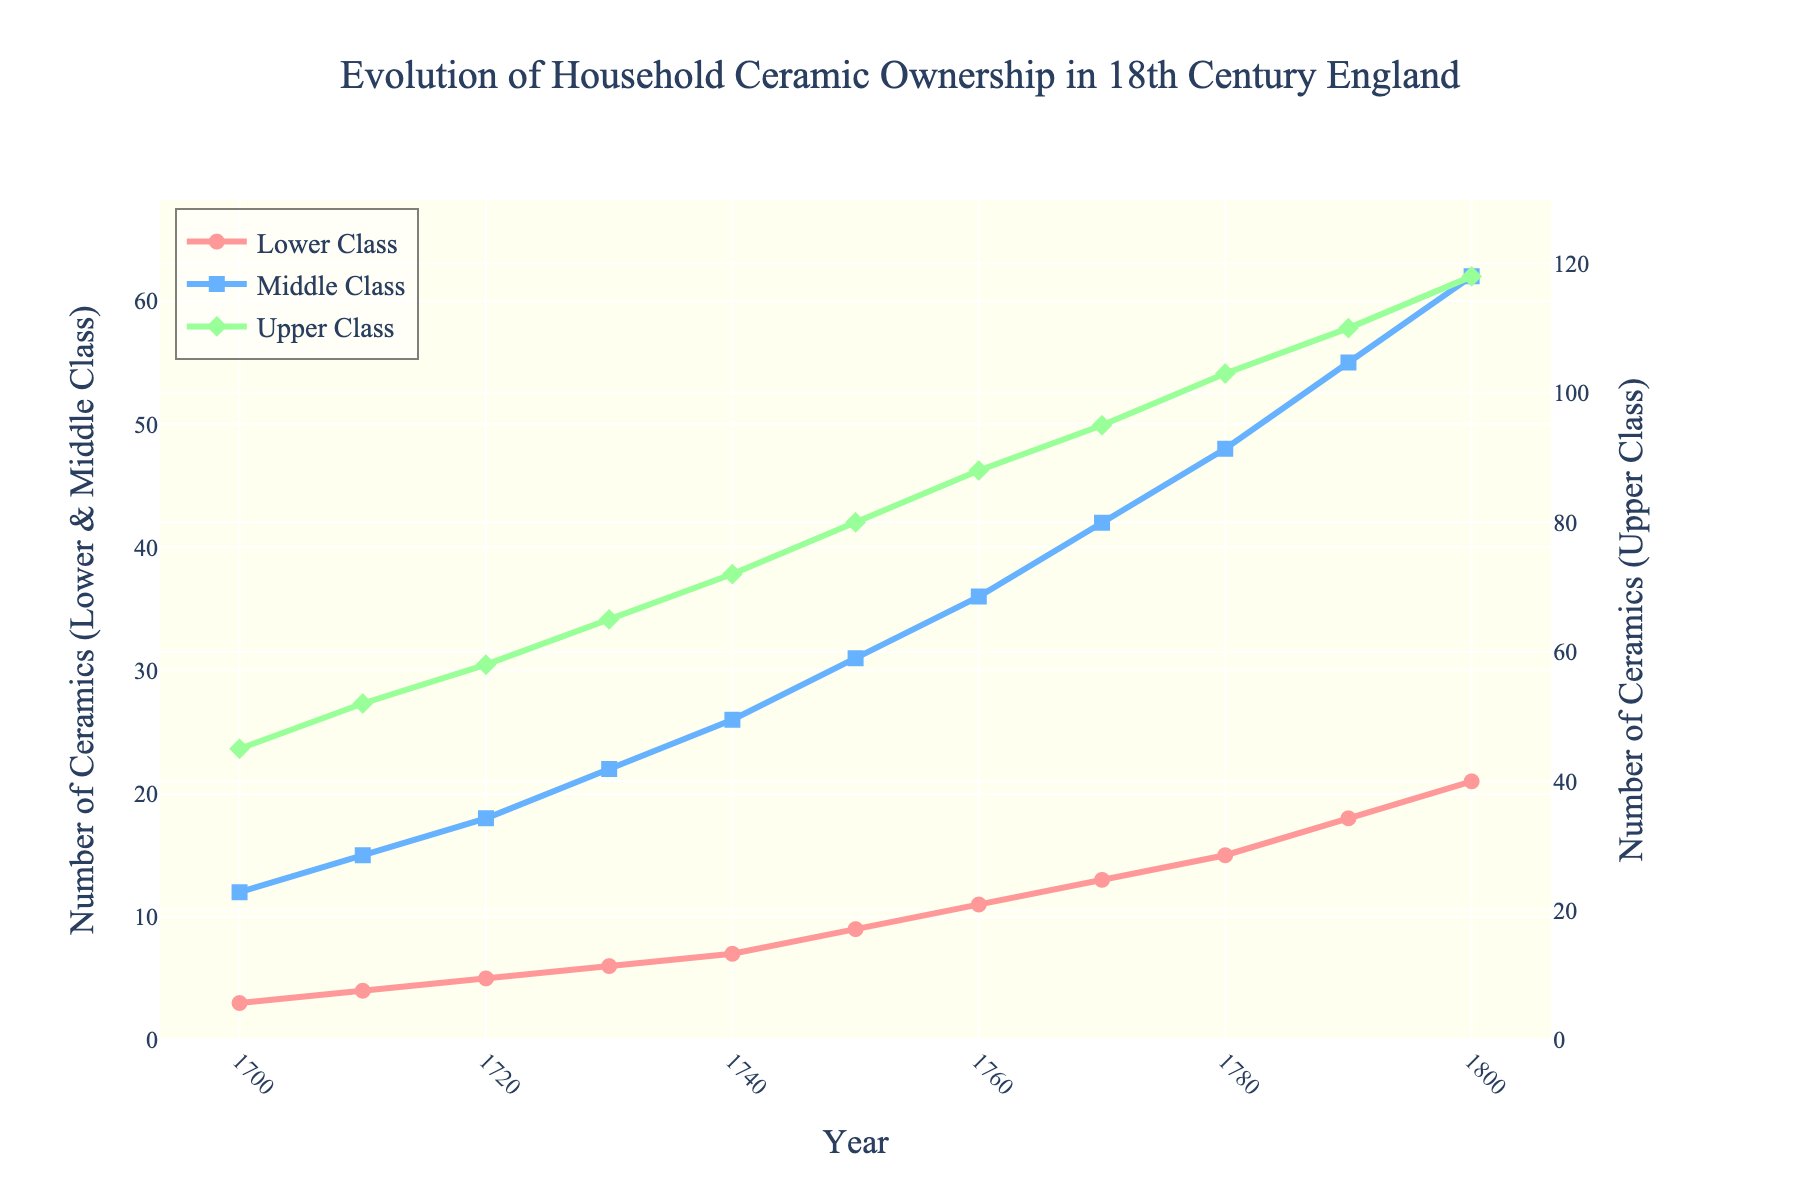What is the increase in the average household ceramic ownership of the Lower Class from 1700 to 1800? In 1700, the Lower Class owned 3 ceramics on average, and in 1800, they owned 21 ceramics. The increase is calculated as 21 - 3 = 18
Answer: 18 By how many ceramics did the Middle Class surpass the Lower Class in 1750? In 1750, the Middle Class owned 31 ceramics, while the Lower Class owned 9 ceramics. The difference is calculated as 31 - 9 = 22
Answer: 22 Which social class had the steepest increase in average household ceramic ownership between 1700 and 1800? To find the steepest increase, compare the differences over time for each class:
- Lower Class: 21 - 3 = 18
- Middle Class: 62 - 12 = 50
- Upper Class: 118 - 45 = 73
The Upper Class had the steepest increase (73).
Answer: Upper Class Compare the average household ceramic ownership of the Upper Class in 1730 with the Middle Class in 1780. Which is greater? In 1730, the Upper Class owned 65 ceramics. In 1780, the Middle Class owned 48 ceramics. Since 65 is greater than 48, the Upper Class in 1730 had greater ownership.
Answer: Upper Class in 1730 What is the average ceramic ownership of the Middle Class over the 18th century? Sum the values for the Middle Class and divide by the number of data points:
(12 + 15 + 18 + 22 + 26 + 31 + 36 + 42 + 48 + 55 + 62) / 11 = 34.27 (approx.)
Answer: 34.27 (approx.) During which decade did the Lower Class experience the highest relative increase in ceramic ownership? Calculate the relative increase for each decade:
- 1700-1710: (4 - 3) / 3 = 0.3333
- 1710-1720: (5 - 4) / 4 = 0.25
- 1720-1730: (6 - 5) / 5 = 0.2
- 1730-1740: (7 - 6) / 6 = 0.1667
- 1740-1750: (9 - 7) / 7 = 0.2857
- 1750-1760: (11 - 9) / 9 = 0.2222
- 1760-1770: (13 - 11) / 11 = 0.1818
- 1770-1780: (15 - 13) / 13 = 0.1538
- 1780-1790: (18 - 15) / 15 = 0.2
- 1790-1800: (21 - 18) / 18 = 0.1667
The highest relative increase occurred during the decade 1700-1710 with a relative increase of 0.3333.
Answer: 1700-1710 Which color represents the Upper Class in the plot? The description specifies the Upper Class is represented in green.
Answer: Green What is the difference in the number of ceramics between the Middle and Lower Classes in 1800? In 1800, the Middle Class owned 62 ceramics and the Lower Class owned 21 ceramics. The difference is 62 - 21 = 41
Answer: 41 In what year did the Middle Class ownership first exceed 25 ceramics? By examining the data, in 1740, the Middle Class owned 26 ceramics, which is the first year they exceeded 25 ceramics.
Answer: 1740 